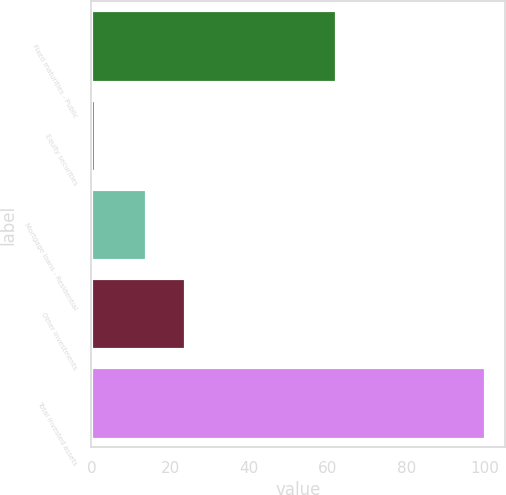Convert chart to OTSL. <chart><loc_0><loc_0><loc_500><loc_500><bar_chart><fcel>Fixed maturities - Public<fcel>Equity securities<fcel>Mortgage loans - Residential<fcel>Other investments<fcel>Total invested assets<nl><fcel>62<fcel>1<fcel>14<fcel>23.9<fcel>100<nl></chart> 